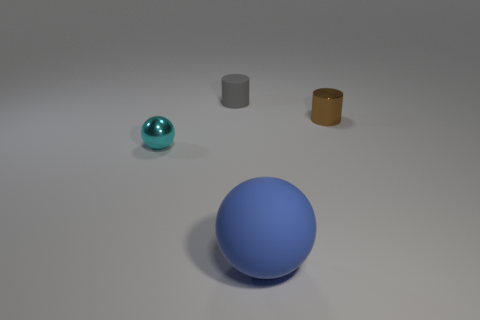There is another object that is the same shape as the large thing; what material is it?
Make the answer very short. Metal. What number of large rubber things have the same shape as the small cyan thing?
Ensure brevity in your answer.  1. The cylinder on the right side of the small matte object to the right of the small cyan ball is made of what material?
Give a very brief answer. Metal. There is a cylinder that is in front of the cylinder behind the small object that is right of the blue thing; what is its size?
Give a very brief answer. Small. How many other things are the same shape as the cyan metallic thing?
Offer a terse response. 1. There is a matte cylinder that is the same size as the shiny ball; what is its color?
Offer a very short reply. Gray. Do the ball to the right of the cyan shiny ball and the gray matte cylinder have the same size?
Your answer should be compact. No. Is the number of tiny cyan balls in front of the blue rubber object the same as the number of green cylinders?
Ensure brevity in your answer.  Yes. What number of things are either cylinders to the right of the blue rubber sphere or big cyan matte cylinders?
Your answer should be very brief. 1. What is the shape of the small object that is behind the cyan ball and to the left of the blue sphere?
Offer a very short reply. Cylinder. 